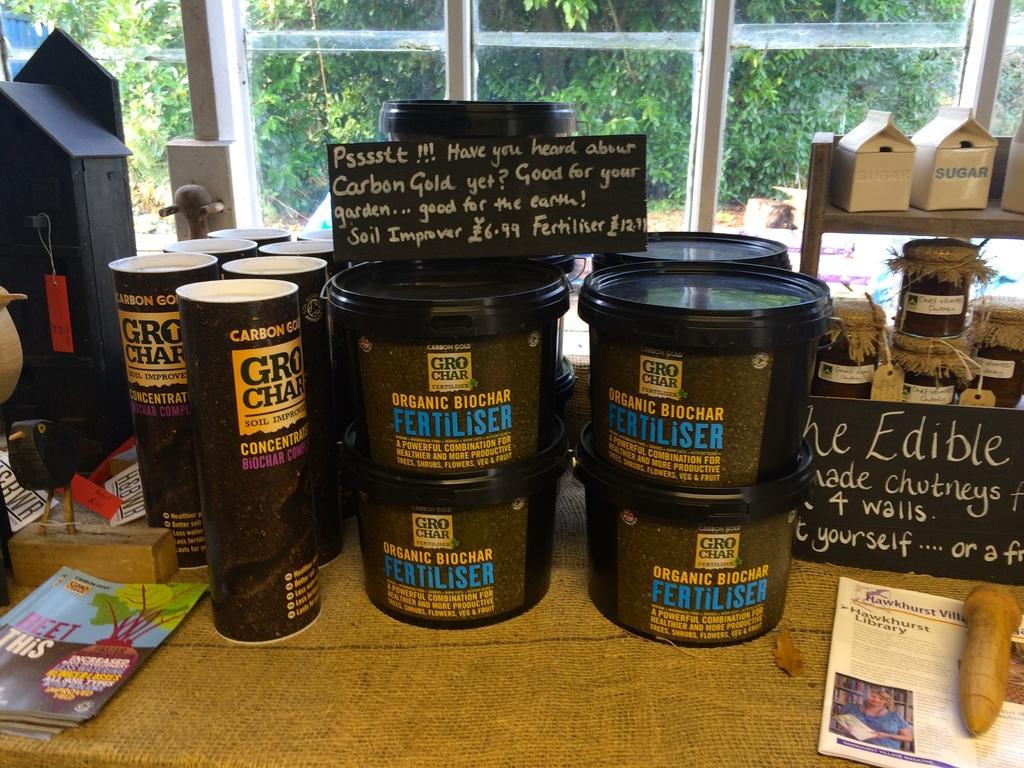Describe this image in one or two sentences. In this picture we can see there are plastic containers, boards, books and some other objects. Behind the plastic container, there are glass windows. Behind the windows, we can see there are trees. 